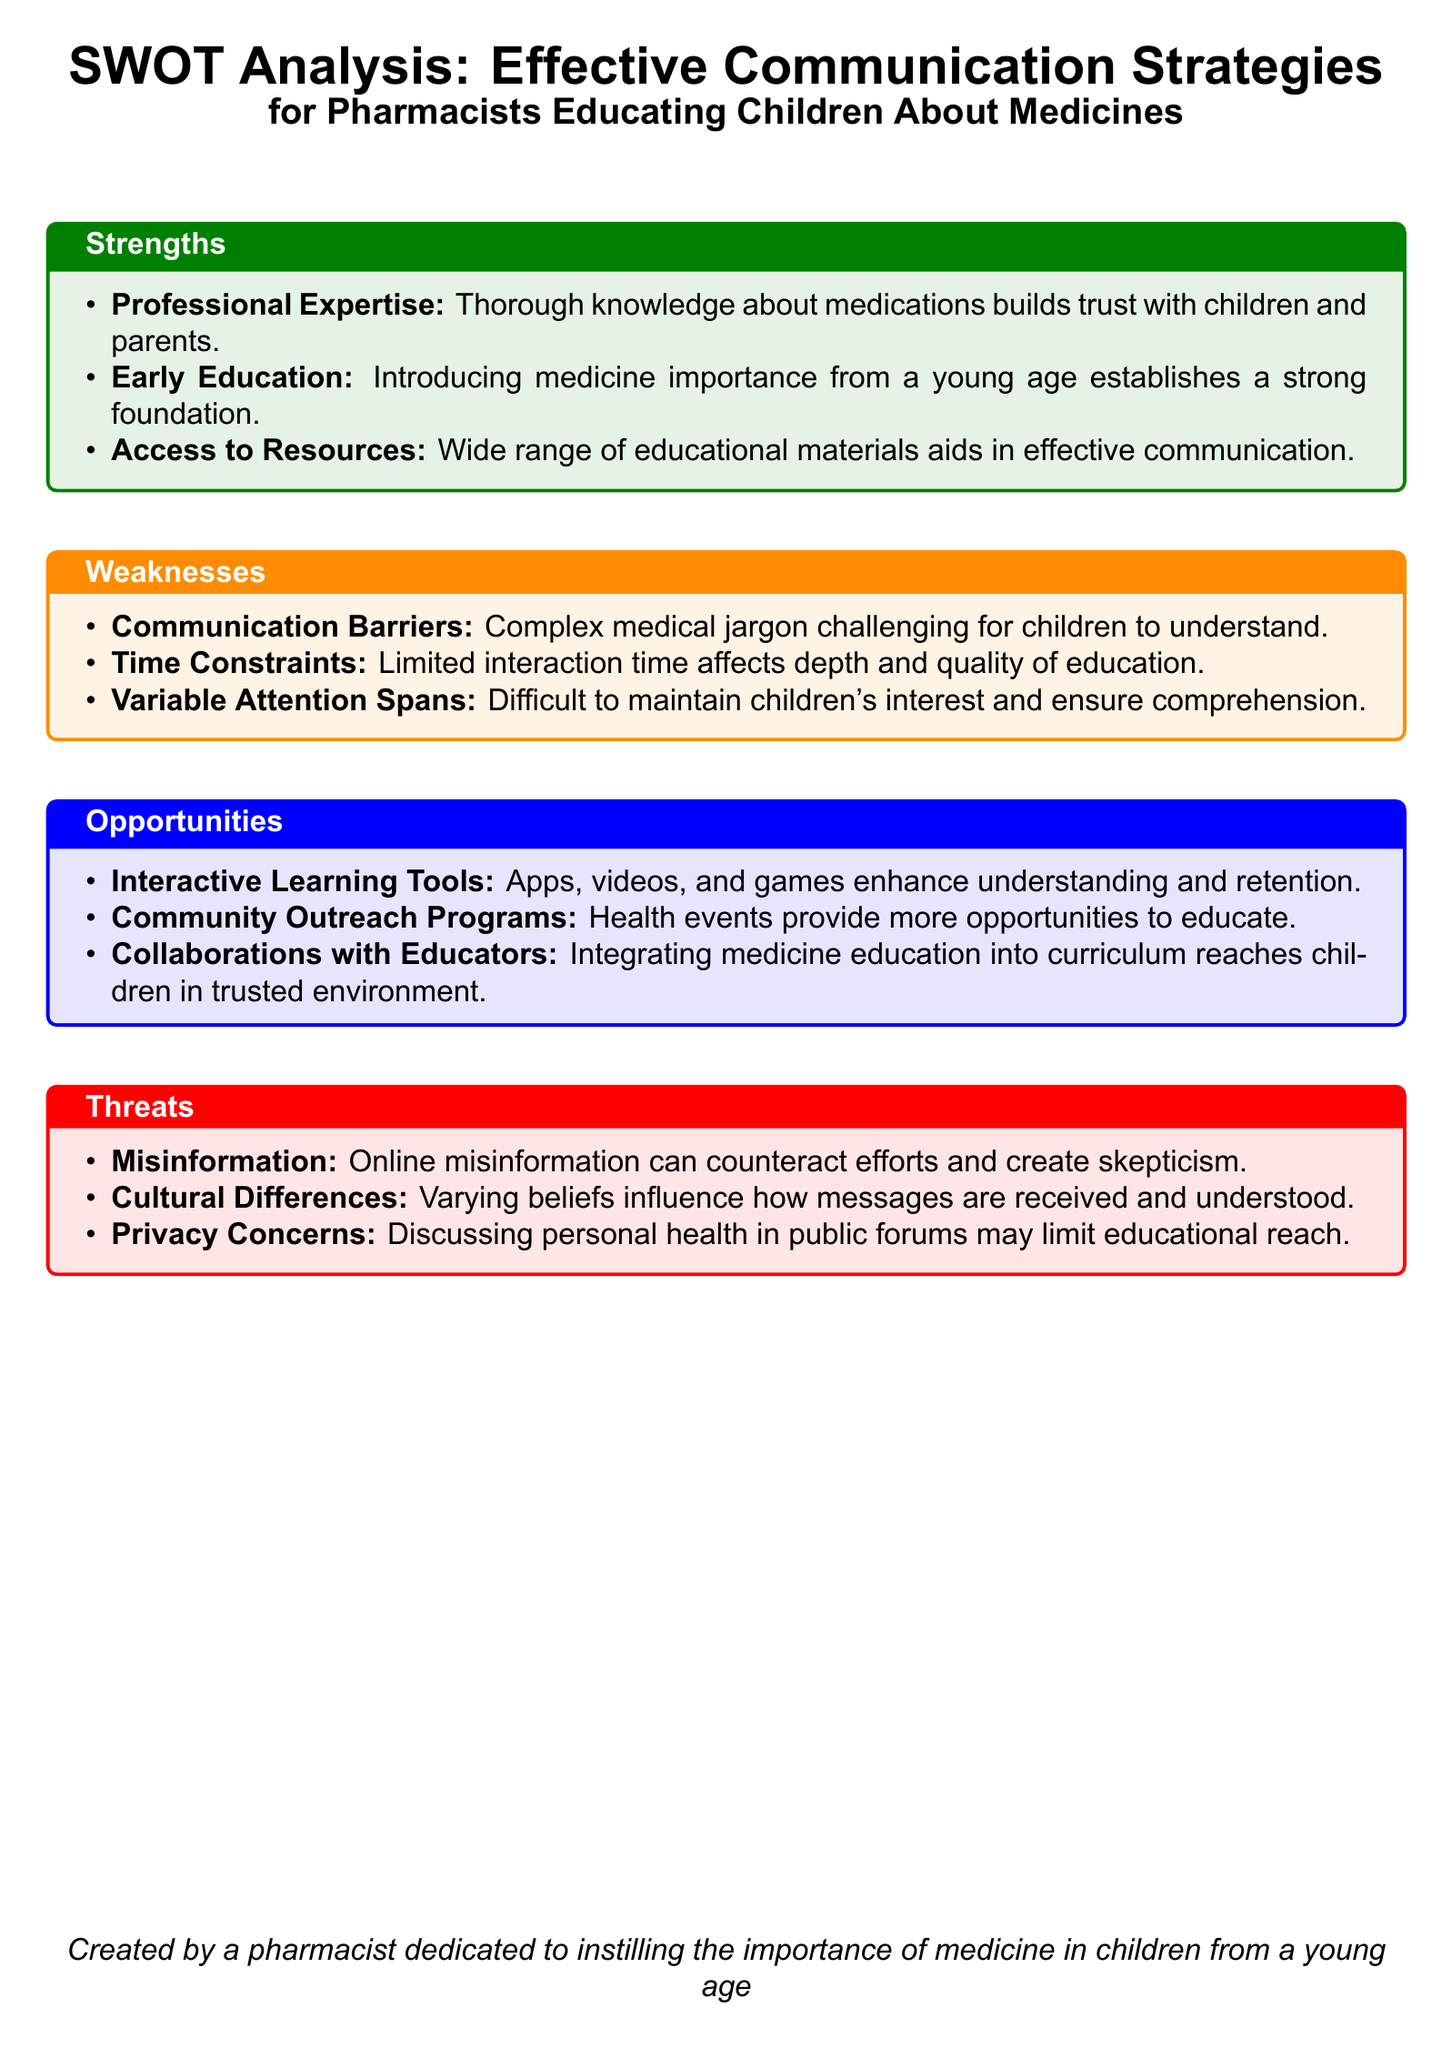What are the strengths of pharmacists in educating children about medicines? The strengths listed in the document include professional expertise, early education, and access to resources.
Answer: Professional Expertise, Early Education, Access to Resources What is a weakness related to children's understanding of medicine? The document states that complex medical jargon is challenging for children to understand.
Answer: Complex medical jargon What type of learning tools is mentioned as an opportunity? The document highlights interactive learning tools such as apps, videos, and games to enhance understanding and retention.
Answer: Interactive Learning Tools How do cultural differences pose a threat in educating children about medicines? The document explains that varying beliefs influence how messages are received and understood, which can affect education efforts.
Answer: Varying beliefs What is one way pharmacists can reach children in a trusted environment? The document suggests collaborations with educators to integrate medicine education into the curriculum as a way to reach children effectively.
Answer: Collaborations with Educators 